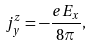Convert formula to latex. <formula><loc_0><loc_0><loc_500><loc_500>j _ { y } ^ { z } = - \frac { e E _ { x } } { 8 \pi } ,</formula> 